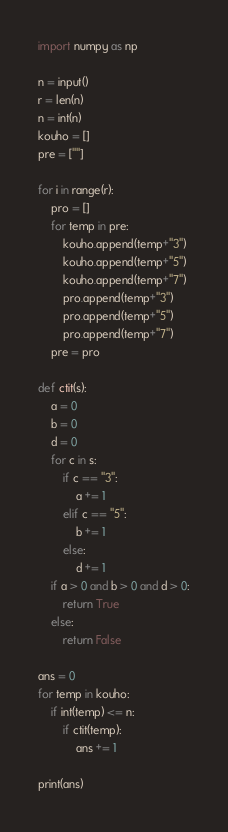<code> <loc_0><loc_0><loc_500><loc_500><_Python_>import numpy as np

n = input()
r = len(n)
n = int(n)
kouho = []
pre = [""]

for i in range(r):
    pro = []
    for temp in pre:
        kouho.append(temp+"3")
        kouho.append(temp+"5")
        kouho.append(temp+"7")
        pro.append(temp+"3")
        pro.append(temp+"5")
        pro.append(temp+"7")
    pre = pro

def ctit(s):
    a = 0
    b = 0
    d = 0
    for c in s:
        if c == "3":
            a += 1
        elif c == "5":
            b += 1
        else:
            d += 1
    if a > 0 and b > 0 and d > 0:
        return True
    else:
        return False

ans = 0
for temp in kouho:
    if int(temp) <= n:
        if ctit(temp):
            ans += 1

print(ans)</code> 